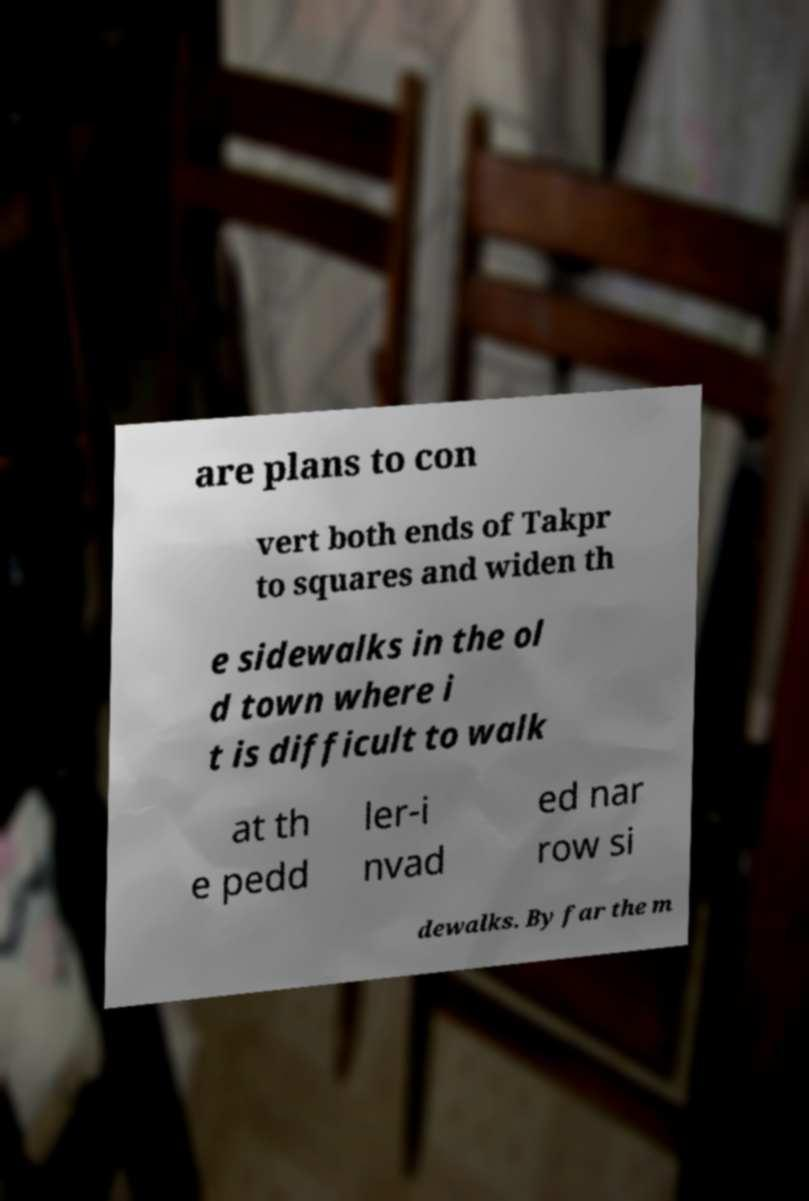There's text embedded in this image that I need extracted. Can you transcribe it verbatim? are plans to con vert both ends of Takpr to squares and widen th e sidewalks in the ol d town where i t is difficult to walk at th e pedd ler-i nvad ed nar row si dewalks. By far the m 